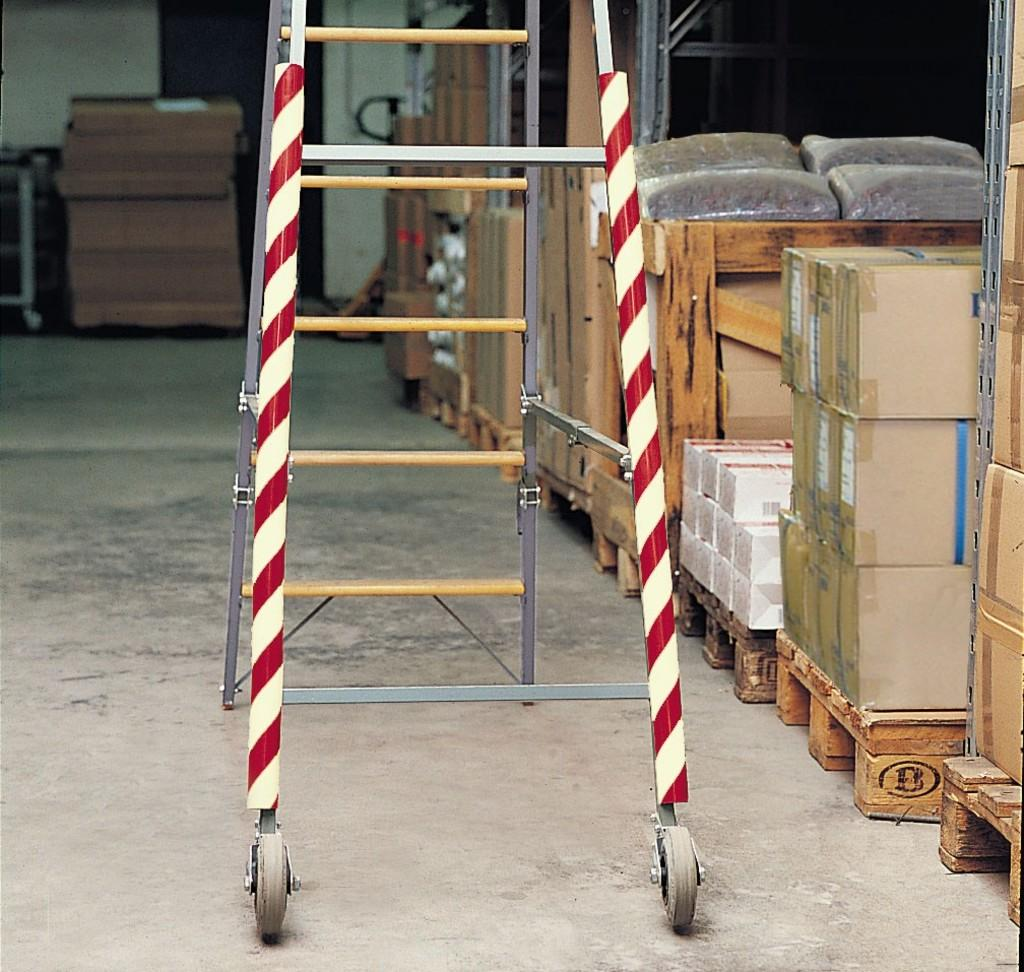What is the main object in the center of the image? There is a ladder in the center of the image. What can be seen in the background of the image? There are cardboard boxes and a wall in the background of the image. Can you hear the donkey braying in the image? There is no donkey present in the image, so it is not possible to hear it braying. 